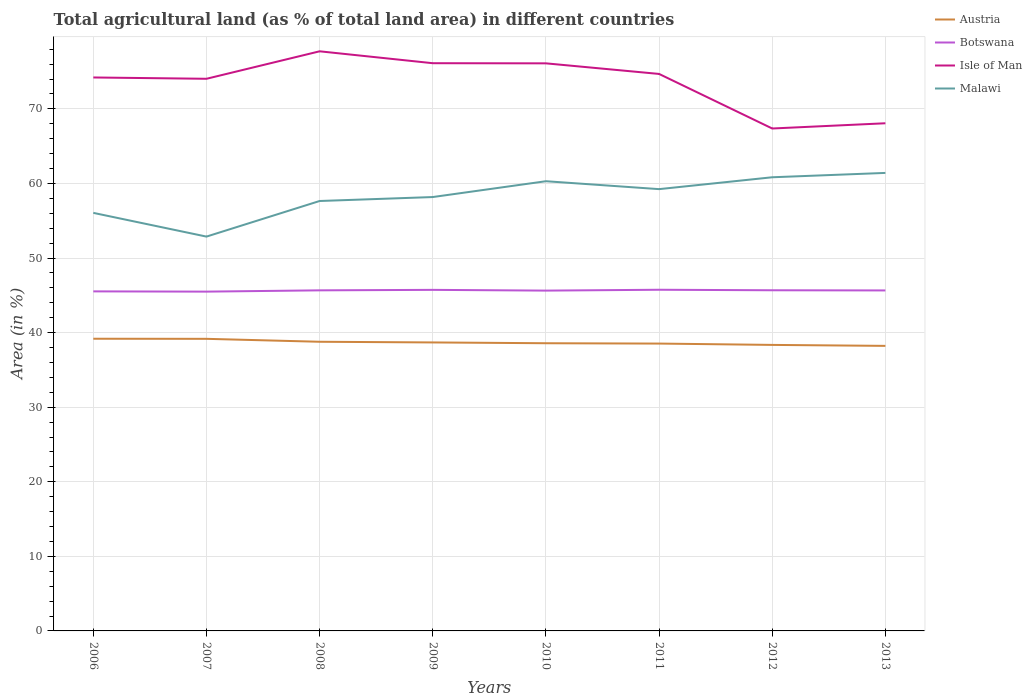Does the line corresponding to Botswana intersect with the line corresponding to Malawi?
Ensure brevity in your answer.  No. Across all years, what is the maximum percentage of agricultural land in Isle of Man?
Keep it short and to the point. 67.37. In which year was the percentage of agricultural land in Austria maximum?
Make the answer very short. 2013. What is the total percentage of agricultural land in Malawi in the graph?
Your answer should be compact. 3.18. What is the difference between the highest and the second highest percentage of agricultural land in Isle of Man?
Make the answer very short. 10.35. Is the percentage of agricultural land in Malawi strictly greater than the percentage of agricultural land in Isle of Man over the years?
Provide a succinct answer. Yes. How many lines are there?
Your answer should be very brief. 4. Are the values on the major ticks of Y-axis written in scientific E-notation?
Keep it short and to the point. No. Where does the legend appear in the graph?
Give a very brief answer. Top right. How many legend labels are there?
Your answer should be very brief. 4. What is the title of the graph?
Offer a very short reply. Total agricultural land (as % of total land area) in different countries. What is the label or title of the X-axis?
Provide a short and direct response. Years. What is the label or title of the Y-axis?
Your answer should be compact. Area (in %). What is the Area (in %) of Austria in 2006?
Ensure brevity in your answer.  39.18. What is the Area (in %) in Botswana in 2006?
Your answer should be compact. 45.53. What is the Area (in %) in Isle of Man in 2006?
Offer a very short reply. 74.21. What is the Area (in %) of Malawi in 2006?
Your response must be concise. 56.06. What is the Area (in %) of Austria in 2007?
Your answer should be compact. 39.17. What is the Area (in %) of Botswana in 2007?
Ensure brevity in your answer.  45.5. What is the Area (in %) in Isle of Man in 2007?
Offer a terse response. 74.04. What is the Area (in %) in Malawi in 2007?
Provide a succinct answer. 52.87. What is the Area (in %) in Austria in 2008?
Provide a short and direct response. 38.77. What is the Area (in %) in Botswana in 2008?
Provide a short and direct response. 45.67. What is the Area (in %) of Isle of Man in 2008?
Give a very brief answer. 77.72. What is the Area (in %) in Malawi in 2008?
Your response must be concise. 57.65. What is the Area (in %) of Austria in 2009?
Keep it short and to the point. 38.68. What is the Area (in %) in Botswana in 2009?
Provide a short and direct response. 45.73. What is the Area (in %) in Isle of Man in 2009?
Ensure brevity in your answer.  76.12. What is the Area (in %) of Malawi in 2009?
Your answer should be very brief. 58.18. What is the Area (in %) of Austria in 2010?
Your response must be concise. 38.58. What is the Area (in %) of Botswana in 2010?
Offer a very short reply. 45.63. What is the Area (in %) in Isle of Man in 2010?
Make the answer very short. 76.11. What is the Area (in %) in Malawi in 2010?
Give a very brief answer. 60.3. What is the Area (in %) of Austria in 2011?
Offer a terse response. 38.53. What is the Area (in %) of Botswana in 2011?
Your response must be concise. 45.75. What is the Area (in %) in Isle of Man in 2011?
Your response must be concise. 74.68. What is the Area (in %) in Malawi in 2011?
Give a very brief answer. 59.24. What is the Area (in %) in Austria in 2012?
Your answer should be compact. 38.35. What is the Area (in %) of Botswana in 2012?
Keep it short and to the point. 45.68. What is the Area (in %) in Isle of Man in 2012?
Provide a succinct answer. 67.37. What is the Area (in %) of Malawi in 2012?
Offer a very short reply. 60.83. What is the Area (in %) of Austria in 2013?
Ensure brevity in your answer.  38.22. What is the Area (in %) in Botswana in 2013?
Give a very brief answer. 45.65. What is the Area (in %) of Isle of Man in 2013?
Make the answer very short. 68.07. What is the Area (in %) in Malawi in 2013?
Provide a short and direct response. 61.41. Across all years, what is the maximum Area (in %) in Austria?
Give a very brief answer. 39.18. Across all years, what is the maximum Area (in %) of Botswana?
Offer a very short reply. 45.75. Across all years, what is the maximum Area (in %) in Isle of Man?
Make the answer very short. 77.72. Across all years, what is the maximum Area (in %) of Malawi?
Your answer should be very brief. 61.41. Across all years, what is the minimum Area (in %) of Austria?
Provide a short and direct response. 38.22. Across all years, what is the minimum Area (in %) in Botswana?
Offer a terse response. 45.5. Across all years, what is the minimum Area (in %) of Isle of Man?
Your answer should be very brief. 67.37. Across all years, what is the minimum Area (in %) of Malawi?
Ensure brevity in your answer.  52.87. What is the total Area (in %) of Austria in the graph?
Your response must be concise. 309.48. What is the total Area (in %) in Botswana in the graph?
Your answer should be compact. 365.14. What is the total Area (in %) in Isle of Man in the graph?
Ensure brevity in your answer.  588.32. What is the total Area (in %) in Malawi in the graph?
Provide a succinct answer. 466.54. What is the difference between the Area (in %) of Austria in 2006 and that in 2007?
Your response must be concise. 0.01. What is the difference between the Area (in %) in Botswana in 2006 and that in 2007?
Your answer should be very brief. 0.03. What is the difference between the Area (in %) of Isle of Man in 2006 and that in 2007?
Ensure brevity in your answer.  0.18. What is the difference between the Area (in %) of Malawi in 2006 and that in 2007?
Offer a terse response. 3.18. What is the difference between the Area (in %) in Austria in 2006 and that in 2008?
Make the answer very short. 0.41. What is the difference between the Area (in %) in Botswana in 2006 and that in 2008?
Your answer should be compact. -0.14. What is the difference between the Area (in %) of Isle of Man in 2006 and that in 2008?
Keep it short and to the point. -3.51. What is the difference between the Area (in %) of Malawi in 2006 and that in 2008?
Your answer should be compact. -1.59. What is the difference between the Area (in %) of Austria in 2006 and that in 2009?
Provide a succinct answer. 0.5. What is the difference between the Area (in %) in Botswana in 2006 and that in 2009?
Provide a short and direct response. -0.2. What is the difference between the Area (in %) in Isle of Man in 2006 and that in 2009?
Provide a short and direct response. -1.91. What is the difference between the Area (in %) in Malawi in 2006 and that in 2009?
Offer a terse response. -2.12. What is the difference between the Area (in %) in Austria in 2006 and that in 2010?
Your response must be concise. 0.6. What is the difference between the Area (in %) in Botswana in 2006 and that in 2010?
Ensure brevity in your answer.  -0.1. What is the difference between the Area (in %) in Isle of Man in 2006 and that in 2010?
Provide a succinct answer. -1.89. What is the difference between the Area (in %) in Malawi in 2006 and that in 2010?
Give a very brief answer. -4.24. What is the difference between the Area (in %) of Austria in 2006 and that in 2011?
Provide a short and direct response. 0.65. What is the difference between the Area (in %) in Botswana in 2006 and that in 2011?
Keep it short and to the point. -0.22. What is the difference between the Area (in %) in Isle of Man in 2006 and that in 2011?
Ensure brevity in your answer.  -0.47. What is the difference between the Area (in %) of Malawi in 2006 and that in 2011?
Offer a very short reply. -3.18. What is the difference between the Area (in %) of Austria in 2006 and that in 2012?
Keep it short and to the point. 0.83. What is the difference between the Area (in %) of Botswana in 2006 and that in 2012?
Offer a terse response. -0.15. What is the difference between the Area (in %) in Isle of Man in 2006 and that in 2012?
Provide a short and direct response. 6.84. What is the difference between the Area (in %) in Malawi in 2006 and that in 2012?
Your response must be concise. -4.77. What is the difference between the Area (in %) in Austria in 2006 and that in 2013?
Offer a terse response. 0.96. What is the difference between the Area (in %) of Botswana in 2006 and that in 2013?
Keep it short and to the point. -0.13. What is the difference between the Area (in %) of Isle of Man in 2006 and that in 2013?
Provide a short and direct response. 6.14. What is the difference between the Area (in %) of Malawi in 2006 and that in 2013?
Make the answer very short. -5.36. What is the difference between the Area (in %) of Austria in 2007 and that in 2008?
Provide a succinct answer. 0.39. What is the difference between the Area (in %) of Botswana in 2007 and that in 2008?
Provide a short and direct response. -0.17. What is the difference between the Area (in %) of Isle of Man in 2007 and that in 2008?
Your answer should be compact. -3.68. What is the difference between the Area (in %) of Malawi in 2007 and that in 2008?
Make the answer very short. -4.77. What is the difference between the Area (in %) of Austria in 2007 and that in 2009?
Make the answer very short. 0.48. What is the difference between the Area (in %) of Botswana in 2007 and that in 2009?
Your response must be concise. -0.24. What is the difference between the Area (in %) of Isle of Man in 2007 and that in 2009?
Offer a very short reply. -2.09. What is the difference between the Area (in %) of Malawi in 2007 and that in 2009?
Offer a very short reply. -5.3. What is the difference between the Area (in %) in Austria in 2007 and that in 2010?
Your answer should be compact. 0.59. What is the difference between the Area (in %) of Botswana in 2007 and that in 2010?
Provide a short and direct response. -0.14. What is the difference between the Area (in %) in Isle of Man in 2007 and that in 2010?
Your answer should be compact. -2.07. What is the difference between the Area (in %) of Malawi in 2007 and that in 2010?
Give a very brief answer. -7.42. What is the difference between the Area (in %) of Austria in 2007 and that in 2011?
Make the answer very short. 0.64. What is the difference between the Area (in %) of Botswana in 2007 and that in 2011?
Keep it short and to the point. -0.25. What is the difference between the Area (in %) in Isle of Man in 2007 and that in 2011?
Offer a terse response. -0.65. What is the difference between the Area (in %) of Malawi in 2007 and that in 2011?
Make the answer very short. -6.36. What is the difference between the Area (in %) in Austria in 2007 and that in 2012?
Offer a terse response. 0.82. What is the difference between the Area (in %) of Botswana in 2007 and that in 2012?
Offer a very short reply. -0.18. What is the difference between the Area (in %) in Malawi in 2007 and that in 2012?
Provide a succinct answer. -7.96. What is the difference between the Area (in %) of Austria in 2007 and that in 2013?
Your answer should be compact. 0.94. What is the difference between the Area (in %) in Botswana in 2007 and that in 2013?
Your response must be concise. -0.16. What is the difference between the Area (in %) in Isle of Man in 2007 and that in 2013?
Provide a succinct answer. 5.96. What is the difference between the Area (in %) in Malawi in 2007 and that in 2013?
Ensure brevity in your answer.  -8.54. What is the difference between the Area (in %) in Austria in 2008 and that in 2009?
Offer a terse response. 0.09. What is the difference between the Area (in %) of Botswana in 2008 and that in 2009?
Your answer should be very brief. -0.07. What is the difference between the Area (in %) of Isle of Man in 2008 and that in 2009?
Your response must be concise. 1.6. What is the difference between the Area (in %) of Malawi in 2008 and that in 2009?
Offer a terse response. -0.53. What is the difference between the Area (in %) of Austria in 2008 and that in 2010?
Your answer should be very brief. 0.2. What is the difference between the Area (in %) in Botswana in 2008 and that in 2010?
Your answer should be very brief. 0.04. What is the difference between the Area (in %) of Isle of Man in 2008 and that in 2010?
Provide a short and direct response. 1.61. What is the difference between the Area (in %) of Malawi in 2008 and that in 2010?
Offer a very short reply. -2.65. What is the difference between the Area (in %) of Austria in 2008 and that in 2011?
Make the answer very short. 0.24. What is the difference between the Area (in %) of Botswana in 2008 and that in 2011?
Make the answer very short. -0.08. What is the difference between the Area (in %) of Isle of Man in 2008 and that in 2011?
Offer a very short reply. 3.04. What is the difference between the Area (in %) in Malawi in 2008 and that in 2011?
Your response must be concise. -1.59. What is the difference between the Area (in %) in Austria in 2008 and that in 2012?
Keep it short and to the point. 0.42. What is the difference between the Area (in %) of Botswana in 2008 and that in 2012?
Give a very brief answer. -0.01. What is the difference between the Area (in %) of Isle of Man in 2008 and that in 2012?
Your answer should be very brief. 10.35. What is the difference between the Area (in %) of Malawi in 2008 and that in 2012?
Ensure brevity in your answer.  -3.18. What is the difference between the Area (in %) in Austria in 2008 and that in 2013?
Give a very brief answer. 0.55. What is the difference between the Area (in %) of Botswana in 2008 and that in 2013?
Provide a succinct answer. 0.01. What is the difference between the Area (in %) in Isle of Man in 2008 and that in 2013?
Your response must be concise. 9.65. What is the difference between the Area (in %) of Malawi in 2008 and that in 2013?
Your response must be concise. -3.77. What is the difference between the Area (in %) in Austria in 2009 and that in 2010?
Keep it short and to the point. 0.11. What is the difference between the Area (in %) in Botswana in 2009 and that in 2010?
Ensure brevity in your answer.  0.1. What is the difference between the Area (in %) in Isle of Man in 2009 and that in 2010?
Your answer should be very brief. 0.02. What is the difference between the Area (in %) in Malawi in 2009 and that in 2010?
Your response must be concise. -2.12. What is the difference between the Area (in %) of Austria in 2009 and that in 2011?
Ensure brevity in your answer.  0.15. What is the difference between the Area (in %) in Botswana in 2009 and that in 2011?
Keep it short and to the point. -0.01. What is the difference between the Area (in %) in Isle of Man in 2009 and that in 2011?
Your answer should be very brief. 1.44. What is the difference between the Area (in %) of Malawi in 2009 and that in 2011?
Your response must be concise. -1.06. What is the difference between the Area (in %) of Austria in 2009 and that in 2012?
Make the answer very short. 0.33. What is the difference between the Area (in %) in Botswana in 2009 and that in 2012?
Provide a short and direct response. 0.05. What is the difference between the Area (in %) in Isle of Man in 2009 and that in 2012?
Give a very brief answer. 8.75. What is the difference between the Area (in %) in Malawi in 2009 and that in 2012?
Ensure brevity in your answer.  -2.65. What is the difference between the Area (in %) of Austria in 2009 and that in 2013?
Give a very brief answer. 0.46. What is the difference between the Area (in %) in Botswana in 2009 and that in 2013?
Your answer should be very brief. 0.08. What is the difference between the Area (in %) in Isle of Man in 2009 and that in 2013?
Give a very brief answer. 8.05. What is the difference between the Area (in %) in Malawi in 2009 and that in 2013?
Offer a terse response. -3.23. What is the difference between the Area (in %) in Austria in 2010 and that in 2011?
Your response must be concise. 0.05. What is the difference between the Area (in %) in Botswana in 2010 and that in 2011?
Your response must be concise. -0.11. What is the difference between the Area (in %) in Isle of Man in 2010 and that in 2011?
Make the answer very short. 1.42. What is the difference between the Area (in %) in Malawi in 2010 and that in 2011?
Provide a succinct answer. 1.06. What is the difference between the Area (in %) of Austria in 2010 and that in 2012?
Ensure brevity in your answer.  0.23. What is the difference between the Area (in %) in Botswana in 2010 and that in 2012?
Provide a short and direct response. -0.05. What is the difference between the Area (in %) in Isle of Man in 2010 and that in 2012?
Make the answer very short. 8.74. What is the difference between the Area (in %) in Malawi in 2010 and that in 2012?
Give a very brief answer. -0.53. What is the difference between the Area (in %) of Austria in 2010 and that in 2013?
Provide a succinct answer. 0.35. What is the difference between the Area (in %) of Botswana in 2010 and that in 2013?
Offer a very short reply. -0.02. What is the difference between the Area (in %) of Isle of Man in 2010 and that in 2013?
Keep it short and to the point. 8.04. What is the difference between the Area (in %) in Malawi in 2010 and that in 2013?
Your answer should be very brief. -1.11. What is the difference between the Area (in %) of Austria in 2011 and that in 2012?
Ensure brevity in your answer.  0.18. What is the difference between the Area (in %) in Botswana in 2011 and that in 2012?
Offer a terse response. 0.07. What is the difference between the Area (in %) in Isle of Man in 2011 and that in 2012?
Offer a terse response. 7.32. What is the difference between the Area (in %) of Malawi in 2011 and that in 2012?
Provide a short and direct response. -1.59. What is the difference between the Area (in %) of Austria in 2011 and that in 2013?
Your response must be concise. 0.31. What is the difference between the Area (in %) of Botswana in 2011 and that in 2013?
Offer a very short reply. 0.09. What is the difference between the Area (in %) in Isle of Man in 2011 and that in 2013?
Provide a succinct answer. 6.61. What is the difference between the Area (in %) in Malawi in 2011 and that in 2013?
Keep it short and to the point. -2.17. What is the difference between the Area (in %) of Austria in 2012 and that in 2013?
Ensure brevity in your answer.  0.13. What is the difference between the Area (in %) of Botswana in 2012 and that in 2013?
Give a very brief answer. 0.02. What is the difference between the Area (in %) in Isle of Man in 2012 and that in 2013?
Your answer should be compact. -0.7. What is the difference between the Area (in %) of Malawi in 2012 and that in 2013?
Ensure brevity in your answer.  -0.58. What is the difference between the Area (in %) of Austria in 2006 and the Area (in %) of Botswana in 2007?
Keep it short and to the point. -6.32. What is the difference between the Area (in %) of Austria in 2006 and the Area (in %) of Isle of Man in 2007?
Ensure brevity in your answer.  -34.86. What is the difference between the Area (in %) in Austria in 2006 and the Area (in %) in Malawi in 2007?
Provide a short and direct response. -13.7. What is the difference between the Area (in %) in Botswana in 2006 and the Area (in %) in Isle of Man in 2007?
Give a very brief answer. -28.51. What is the difference between the Area (in %) of Botswana in 2006 and the Area (in %) of Malawi in 2007?
Your answer should be very brief. -7.34. What is the difference between the Area (in %) of Isle of Man in 2006 and the Area (in %) of Malawi in 2007?
Keep it short and to the point. 21.34. What is the difference between the Area (in %) of Austria in 2006 and the Area (in %) of Botswana in 2008?
Keep it short and to the point. -6.49. What is the difference between the Area (in %) of Austria in 2006 and the Area (in %) of Isle of Man in 2008?
Offer a terse response. -38.54. What is the difference between the Area (in %) in Austria in 2006 and the Area (in %) in Malawi in 2008?
Offer a very short reply. -18.47. What is the difference between the Area (in %) in Botswana in 2006 and the Area (in %) in Isle of Man in 2008?
Offer a very short reply. -32.19. What is the difference between the Area (in %) in Botswana in 2006 and the Area (in %) in Malawi in 2008?
Offer a terse response. -12.12. What is the difference between the Area (in %) of Isle of Man in 2006 and the Area (in %) of Malawi in 2008?
Make the answer very short. 16.56. What is the difference between the Area (in %) of Austria in 2006 and the Area (in %) of Botswana in 2009?
Provide a succinct answer. -6.55. What is the difference between the Area (in %) of Austria in 2006 and the Area (in %) of Isle of Man in 2009?
Make the answer very short. -36.94. What is the difference between the Area (in %) of Austria in 2006 and the Area (in %) of Malawi in 2009?
Your answer should be very brief. -19. What is the difference between the Area (in %) in Botswana in 2006 and the Area (in %) in Isle of Man in 2009?
Offer a very short reply. -30.59. What is the difference between the Area (in %) of Botswana in 2006 and the Area (in %) of Malawi in 2009?
Make the answer very short. -12.65. What is the difference between the Area (in %) in Isle of Man in 2006 and the Area (in %) in Malawi in 2009?
Give a very brief answer. 16.03. What is the difference between the Area (in %) in Austria in 2006 and the Area (in %) in Botswana in 2010?
Offer a very short reply. -6.45. What is the difference between the Area (in %) in Austria in 2006 and the Area (in %) in Isle of Man in 2010?
Offer a terse response. -36.93. What is the difference between the Area (in %) of Austria in 2006 and the Area (in %) of Malawi in 2010?
Your answer should be compact. -21.12. What is the difference between the Area (in %) in Botswana in 2006 and the Area (in %) in Isle of Man in 2010?
Provide a succinct answer. -30.58. What is the difference between the Area (in %) of Botswana in 2006 and the Area (in %) of Malawi in 2010?
Provide a succinct answer. -14.77. What is the difference between the Area (in %) of Isle of Man in 2006 and the Area (in %) of Malawi in 2010?
Your response must be concise. 13.91. What is the difference between the Area (in %) in Austria in 2006 and the Area (in %) in Botswana in 2011?
Your answer should be compact. -6.57. What is the difference between the Area (in %) in Austria in 2006 and the Area (in %) in Isle of Man in 2011?
Provide a succinct answer. -35.51. What is the difference between the Area (in %) in Austria in 2006 and the Area (in %) in Malawi in 2011?
Provide a short and direct response. -20.06. What is the difference between the Area (in %) of Botswana in 2006 and the Area (in %) of Isle of Man in 2011?
Offer a terse response. -29.15. What is the difference between the Area (in %) in Botswana in 2006 and the Area (in %) in Malawi in 2011?
Offer a very short reply. -13.71. What is the difference between the Area (in %) of Isle of Man in 2006 and the Area (in %) of Malawi in 2011?
Your answer should be compact. 14.97. What is the difference between the Area (in %) in Austria in 2006 and the Area (in %) in Botswana in 2012?
Your response must be concise. -6.5. What is the difference between the Area (in %) in Austria in 2006 and the Area (in %) in Isle of Man in 2012?
Keep it short and to the point. -28.19. What is the difference between the Area (in %) of Austria in 2006 and the Area (in %) of Malawi in 2012?
Your response must be concise. -21.65. What is the difference between the Area (in %) of Botswana in 2006 and the Area (in %) of Isle of Man in 2012?
Your answer should be very brief. -21.84. What is the difference between the Area (in %) of Botswana in 2006 and the Area (in %) of Malawi in 2012?
Make the answer very short. -15.3. What is the difference between the Area (in %) in Isle of Man in 2006 and the Area (in %) in Malawi in 2012?
Provide a short and direct response. 13.38. What is the difference between the Area (in %) of Austria in 2006 and the Area (in %) of Botswana in 2013?
Make the answer very short. -6.48. What is the difference between the Area (in %) in Austria in 2006 and the Area (in %) in Isle of Man in 2013?
Make the answer very short. -28.89. What is the difference between the Area (in %) in Austria in 2006 and the Area (in %) in Malawi in 2013?
Offer a terse response. -22.23. What is the difference between the Area (in %) of Botswana in 2006 and the Area (in %) of Isle of Man in 2013?
Your answer should be compact. -22.54. What is the difference between the Area (in %) of Botswana in 2006 and the Area (in %) of Malawi in 2013?
Give a very brief answer. -15.88. What is the difference between the Area (in %) of Isle of Man in 2006 and the Area (in %) of Malawi in 2013?
Provide a succinct answer. 12.8. What is the difference between the Area (in %) of Austria in 2007 and the Area (in %) of Botswana in 2008?
Keep it short and to the point. -6.5. What is the difference between the Area (in %) in Austria in 2007 and the Area (in %) in Isle of Man in 2008?
Ensure brevity in your answer.  -38.55. What is the difference between the Area (in %) in Austria in 2007 and the Area (in %) in Malawi in 2008?
Offer a terse response. -18.48. What is the difference between the Area (in %) in Botswana in 2007 and the Area (in %) in Isle of Man in 2008?
Your answer should be compact. -32.22. What is the difference between the Area (in %) in Botswana in 2007 and the Area (in %) in Malawi in 2008?
Offer a terse response. -12.15. What is the difference between the Area (in %) of Isle of Man in 2007 and the Area (in %) of Malawi in 2008?
Give a very brief answer. 16.39. What is the difference between the Area (in %) in Austria in 2007 and the Area (in %) in Botswana in 2009?
Keep it short and to the point. -6.57. What is the difference between the Area (in %) in Austria in 2007 and the Area (in %) in Isle of Man in 2009?
Ensure brevity in your answer.  -36.96. What is the difference between the Area (in %) in Austria in 2007 and the Area (in %) in Malawi in 2009?
Provide a succinct answer. -19.01. What is the difference between the Area (in %) of Botswana in 2007 and the Area (in %) of Isle of Man in 2009?
Your answer should be very brief. -30.63. What is the difference between the Area (in %) of Botswana in 2007 and the Area (in %) of Malawi in 2009?
Make the answer very short. -12.68. What is the difference between the Area (in %) in Isle of Man in 2007 and the Area (in %) in Malawi in 2009?
Make the answer very short. 15.86. What is the difference between the Area (in %) in Austria in 2007 and the Area (in %) in Botswana in 2010?
Ensure brevity in your answer.  -6.47. What is the difference between the Area (in %) in Austria in 2007 and the Area (in %) in Isle of Man in 2010?
Your response must be concise. -36.94. What is the difference between the Area (in %) of Austria in 2007 and the Area (in %) of Malawi in 2010?
Make the answer very short. -21.13. What is the difference between the Area (in %) of Botswana in 2007 and the Area (in %) of Isle of Man in 2010?
Offer a very short reply. -30.61. What is the difference between the Area (in %) in Botswana in 2007 and the Area (in %) in Malawi in 2010?
Offer a terse response. -14.8. What is the difference between the Area (in %) in Isle of Man in 2007 and the Area (in %) in Malawi in 2010?
Offer a terse response. 13.74. What is the difference between the Area (in %) in Austria in 2007 and the Area (in %) in Botswana in 2011?
Keep it short and to the point. -6.58. What is the difference between the Area (in %) in Austria in 2007 and the Area (in %) in Isle of Man in 2011?
Make the answer very short. -35.52. What is the difference between the Area (in %) in Austria in 2007 and the Area (in %) in Malawi in 2011?
Provide a succinct answer. -20.07. What is the difference between the Area (in %) in Botswana in 2007 and the Area (in %) in Isle of Man in 2011?
Give a very brief answer. -29.19. What is the difference between the Area (in %) of Botswana in 2007 and the Area (in %) of Malawi in 2011?
Offer a terse response. -13.74. What is the difference between the Area (in %) in Isle of Man in 2007 and the Area (in %) in Malawi in 2011?
Offer a terse response. 14.8. What is the difference between the Area (in %) of Austria in 2007 and the Area (in %) of Botswana in 2012?
Offer a very short reply. -6.51. What is the difference between the Area (in %) in Austria in 2007 and the Area (in %) in Isle of Man in 2012?
Provide a succinct answer. -28.2. What is the difference between the Area (in %) of Austria in 2007 and the Area (in %) of Malawi in 2012?
Provide a succinct answer. -21.66. What is the difference between the Area (in %) in Botswana in 2007 and the Area (in %) in Isle of Man in 2012?
Offer a very short reply. -21.87. What is the difference between the Area (in %) of Botswana in 2007 and the Area (in %) of Malawi in 2012?
Provide a succinct answer. -15.33. What is the difference between the Area (in %) in Isle of Man in 2007 and the Area (in %) in Malawi in 2012?
Give a very brief answer. 13.21. What is the difference between the Area (in %) in Austria in 2007 and the Area (in %) in Botswana in 2013?
Ensure brevity in your answer.  -6.49. What is the difference between the Area (in %) in Austria in 2007 and the Area (in %) in Isle of Man in 2013?
Provide a short and direct response. -28.9. What is the difference between the Area (in %) in Austria in 2007 and the Area (in %) in Malawi in 2013?
Provide a succinct answer. -22.25. What is the difference between the Area (in %) of Botswana in 2007 and the Area (in %) of Isle of Man in 2013?
Keep it short and to the point. -22.57. What is the difference between the Area (in %) in Botswana in 2007 and the Area (in %) in Malawi in 2013?
Keep it short and to the point. -15.92. What is the difference between the Area (in %) of Isle of Man in 2007 and the Area (in %) of Malawi in 2013?
Make the answer very short. 12.62. What is the difference between the Area (in %) of Austria in 2008 and the Area (in %) of Botswana in 2009?
Offer a terse response. -6.96. What is the difference between the Area (in %) in Austria in 2008 and the Area (in %) in Isle of Man in 2009?
Offer a terse response. -37.35. What is the difference between the Area (in %) in Austria in 2008 and the Area (in %) in Malawi in 2009?
Provide a succinct answer. -19.4. What is the difference between the Area (in %) in Botswana in 2008 and the Area (in %) in Isle of Man in 2009?
Provide a short and direct response. -30.46. What is the difference between the Area (in %) of Botswana in 2008 and the Area (in %) of Malawi in 2009?
Keep it short and to the point. -12.51. What is the difference between the Area (in %) in Isle of Man in 2008 and the Area (in %) in Malawi in 2009?
Provide a succinct answer. 19.54. What is the difference between the Area (in %) in Austria in 2008 and the Area (in %) in Botswana in 2010?
Your answer should be compact. -6.86. What is the difference between the Area (in %) in Austria in 2008 and the Area (in %) in Isle of Man in 2010?
Your answer should be compact. -37.33. What is the difference between the Area (in %) of Austria in 2008 and the Area (in %) of Malawi in 2010?
Give a very brief answer. -21.53. What is the difference between the Area (in %) in Botswana in 2008 and the Area (in %) in Isle of Man in 2010?
Keep it short and to the point. -30.44. What is the difference between the Area (in %) in Botswana in 2008 and the Area (in %) in Malawi in 2010?
Provide a short and direct response. -14.63. What is the difference between the Area (in %) in Isle of Man in 2008 and the Area (in %) in Malawi in 2010?
Make the answer very short. 17.42. What is the difference between the Area (in %) in Austria in 2008 and the Area (in %) in Botswana in 2011?
Provide a succinct answer. -6.97. What is the difference between the Area (in %) in Austria in 2008 and the Area (in %) in Isle of Man in 2011?
Provide a short and direct response. -35.91. What is the difference between the Area (in %) in Austria in 2008 and the Area (in %) in Malawi in 2011?
Your response must be concise. -20.47. What is the difference between the Area (in %) of Botswana in 2008 and the Area (in %) of Isle of Man in 2011?
Provide a succinct answer. -29.02. What is the difference between the Area (in %) in Botswana in 2008 and the Area (in %) in Malawi in 2011?
Offer a terse response. -13.57. What is the difference between the Area (in %) of Isle of Man in 2008 and the Area (in %) of Malawi in 2011?
Offer a terse response. 18.48. What is the difference between the Area (in %) in Austria in 2008 and the Area (in %) in Botswana in 2012?
Ensure brevity in your answer.  -6.9. What is the difference between the Area (in %) in Austria in 2008 and the Area (in %) in Isle of Man in 2012?
Keep it short and to the point. -28.6. What is the difference between the Area (in %) in Austria in 2008 and the Area (in %) in Malawi in 2012?
Give a very brief answer. -22.06. What is the difference between the Area (in %) in Botswana in 2008 and the Area (in %) in Isle of Man in 2012?
Offer a terse response. -21.7. What is the difference between the Area (in %) of Botswana in 2008 and the Area (in %) of Malawi in 2012?
Give a very brief answer. -15.16. What is the difference between the Area (in %) of Isle of Man in 2008 and the Area (in %) of Malawi in 2012?
Offer a very short reply. 16.89. What is the difference between the Area (in %) of Austria in 2008 and the Area (in %) of Botswana in 2013?
Provide a short and direct response. -6.88. What is the difference between the Area (in %) in Austria in 2008 and the Area (in %) in Isle of Man in 2013?
Provide a short and direct response. -29.3. What is the difference between the Area (in %) in Austria in 2008 and the Area (in %) in Malawi in 2013?
Give a very brief answer. -22.64. What is the difference between the Area (in %) in Botswana in 2008 and the Area (in %) in Isle of Man in 2013?
Your answer should be compact. -22.4. What is the difference between the Area (in %) in Botswana in 2008 and the Area (in %) in Malawi in 2013?
Offer a very short reply. -15.75. What is the difference between the Area (in %) of Isle of Man in 2008 and the Area (in %) of Malawi in 2013?
Offer a very short reply. 16.31. What is the difference between the Area (in %) in Austria in 2009 and the Area (in %) in Botswana in 2010?
Give a very brief answer. -6.95. What is the difference between the Area (in %) of Austria in 2009 and the Area (in %) of Isle of Man in 2010?
Your response must be concise. -37.42. What is the difference between the Area (in %) in Austria in 2009 and the Area (in %) in Malawi in 2010?
Provide a short and direct response. -21.62. What is the difference between the Area (in %) in Botswana in 2009 and the Area (in %) in Isle of Man in 2010?
Make the answer very short. -30.37. What is the difference between the Area (in %) of Botswana in 2009 and the Area (in %) of Malawi in 2010?
Provide a short and direct response. -14.57. What is the difference between the Area (in %) of Isle of Man in 2009 and the Area (in %) of Malawi in 2010?
Your answer should be compact. 15.82. What is the difference between the Area (in %) in Austria in 2009 and the Area (in %) in Botswana in 2011?
Provide a succinct answer. -7.06. What is the difference between the Area (in %) in Austria in 2009 and the Area (in %) in Isle of Man in 2011?
Your answer should be very brief. -36. What is the difference between the Area (in %) in Austria in 2009 and the Area (in %) in Malawi in 2011?
Your answer should be compact. -20.56. What is the difference between the Area (in %) in Botswana in 2009 and the Area (in %) in Isle of Man in 2011?
Ensure brevity in your answer.  -28.95. What is the difference between the Area (in %) in Botswana in 2009 and the Area (in %) in Malawi in 2011?
Your answer should be very brief. -13.51. What is the difference between the Area (in %) in Isle of Man in 2009 and the Area (in %) in Malawi in 2011?
Your answer should be compact. 16.88. What is the difference between the Area (in %) of Austria in 2009 and the Area (in %) of Botswana in 2012?
Offer a terse response. -7. What is the difference between the Area (in %) of Austria in 2009 and the Area (in %) of Isle of Man in 2012?
Make the answer very short. -28.69. What is the difference between the Area (in %) in Austria in 2009 and the Area (in %) in Malawi in 2012?
Your response must be concise. -22.15. What is the difference between the Area (in %) in Botswana in 2009 and the Area (in %) in Isle of Man in 2012?
Provide a succinct answer. -21.64. What is the difference between the Area (in %) of Botswana in 2009 and the Area (in %) of Malawi in 2012?
Your answer should be compact. -15.1. What is the difference between the Area (in %) in Isle of Man in 2009 and the Area (in %) in Malawi in 2012?
Your answer should be compact. 15.29. What is the difference between the Area (in %) in Austria in 2009 and the Area (in %) in Botswana in 2013?
Your response must be concise. -6.97. What is the difference between the Area (in %) in Austria in 2009 and the Area (in %) in Isle of Man in 2013?
Your answer should be very brief. -29.39. What is the difference between the Area (in %) of Austria in 2009 and the Area (in %) of Malawi in 2013?
Your answer should be very brief. -22.73. What is the difference between the Area (in %) in Botswana in 2009 and the Area (in %) in Isle of Man in 2013?
Your answer should be very brief. -22.34. What is the difference between the Area (in %) in Botswana in 2009 and the Area (in %) in Malawi in 2013?
Provide a succinct answer. -15.68. What is the difference between the Area (in %) in Isle of Man in 2009 and the Area (in %) in Malawi in 2013?
Your response must be concise. 14.71. What is the difference between the Area (in %) in Austria in 2010 and the Area (in %) in Botswana in 2011?
Keep it short and to the point. -7.17. What is the difference between the Area (in %) of Austria in 2010 and the Area (in %) of Isle of Man in 2011?
Make the answer very short. -36.11. What is the difference between the Area (in %) of Austria in 2010 and the Area (in %) of Malawi in 2011?
Make the answer very short. -20.66. What is the difference between the Area (in %) in Botswana in 2010 and the Area (in %) in Isle of Man in 2011?
Offer a terse response. -29.05. What is the difference between the Area (in %) of Botswana in 2010 and the Area (in %) of Malawi in 2011?
Your answer should be very brief. -13.61. What is the difference between the Area (in %) in Isle of Man in 2010 and the Area (in %) in Malawi in 2011?
Provide a short and direct response. 16.87. What is the difference between the Area (in %) in Austria in 2010 and the Area (in %) in Botswana in 2012?
Provide a succinct answer. -7.1. What is the difference between the Area (in %) of Austria in 2010 and the Area (in %) of Isle of Man in 2012?
Offer a very short reply. -28.79. What is the difference between the Area (in %) of Austria in 2010 and the Area (in %) of Malawi in 2012?
Ensure brevity in your answer.  -22.25. What is the difference between the Area (in %) of Botswana in 2010 and the Area (in %) of Isle of Man in 2012?
Offer a terse response. -21.74. What is the difference between the Area (in %) of Botswana in 2010 and the Area (in %) of Malawi in 2012?
Keep it short and to the point. -15.2. What is the difference between the Area (in %) of Isle of Man in 2010 and the Area (in %) of Malawi in 2012?
Provide a succinct answer. 15.28. What is the difference between the Area (in %) of Austria in 2010 and the Area (in %) of Botswana in 2013?
Your answer should be very brief. -7.08. What is the difference between the Area (in %) in Austria in 2010 and the Area (in %) in Isle of Man in 2013?
Provide a short and direct response. -29.49. What is the difference between the Area (in %) of Austria in 2010 and the Area (in %) of Malawi in 2013?
Offer a terse response. -22.84. What is the difference between the Area (in %) in Botswana in 2010 and the Area (in %) in Isle of Man in 2013?
Provide a short and direct response. -22.44. What is the difference between the Area (in %) of Botswana in 2010 and the Area (in %) of Malawi in 2013?
Offer a terse response. -15.78. What is the difference between the Area (in %) of Isle of Man in 2010 and the Area (in %) of Malawi in 2013?
Your answer should be very brief. 14.69. What is the difference between the Area (in %) in Austria in 2011 and the Area (in %) in Botswana in 2012?
Provide a short and direct response. -7.15. What is the difference between the Area (in %) in Austria in 2011 and the Area (in %) in Isle of Man in 2012?
Provide a short and direct response. -28.84. What is the difference between the Area (in %) of Austria in 2011 and the Area (in %) of Malawi in 2012?
Your response must be concise. -22.3. What is the difference between the Area (in %) in Botswana in 2011 and the Area (in %) in Isle of Man in 2012?
Ensure brevity in your answer.  -21.62. What is the difference between the Area (in %) in Botswana in 2011 and the Area (in %) in Malawi in 2012?
Give a very brief answer. -15.08. What is the difference between the Area (in %) of Isle of Man in 2011 and the Area (in %) of Malawi in 2012?
Offer a very short reply. 13.85. What is the difference between the Area (in %) in Austria in 2011 and the Area (in %) in Botswana in 2013?
Give a very brief answer. -7.12. What is the difference between the Area (in %) of Austria in 2011 and the Area (in %) of Isle of Man in 2013?
Provide a short and direct response. -29.54. What is the difference between the Area (in %) in Austria in 2011 and the Area (in %) in Malawi in 2013?
Offer a terse response. -22.88. What is the difference between the Area (in %) in Botswana in 2011 and the Area (in %) in Isle of Man in 2013?
Offer a very short reply. -22.32. What is the difference between the Area (in %) of Botswana in 2011 and the Area (in %) of Malawi in 2013?
Give a very brief answer. -15.67. What is the difference between the Area (in %) in Isle of Man in 2011 and the Area (in %) in Malawi in 2013?
Your answer should be compact. 13.27. What is the difference between the Area (in %) of Austria in 2012 and the Area (in %) of Botswana in 2013?
Ensure brevity in your answer.  -7.3. What is the difference between the Area (in %) in Austria in 2012 and the Area (in %) in Isle of Man in 2013?
Your response must be concise. -29.72. What is the difference between the Area (in %) in Austria in 2012 and the Area (in %) in Malawi in 2013?
Provide a short and direct response. -23.06. What is the difference between the Area (in %) of Botswana in 2012 and the Area (in %) of Isle of Man in 2013?
Provide a succinct answer. -22.39. What is the difference between the Area (in %) in Botswana in 2012 and the Area (in %) in Malawi in 2013?
Your answer should be compact. -15.73. What is the difference between the Area (in %) of Isle of Man in 2012 and the Area (in %) of Malawi in 2013?
Give a very brief answer. 5.96. What is the average Area (in %) in Austria per year?
Offer a very short reply. 38.68. What is the average Area (in %) in Botswana per year?
Keep it short and to the point. 45.64. What is the average Area (in %) in Isle of Man per year?
Your response must be concise. 73.54. What is the average Area (in %) of Malawi per year?
Your answer should be very brief. 58.32. In the year 2006, what is the difference between the Area (in %) of Austria and Area (in %) of Botswana?
Your answer should be very brief. -6.35. In the year 2006, what is the difference between the Area (in %) in Austria and Area (in %) in Isle of Man?
Give a very brief answer. -35.03. In the year 2006, what is the difference between the Area (in %) in Austria and Area (in %) in Malawi?
Keep it short and to the point. -16.88. In the year 2006, what is the difference between the Area (in %) of Botswana and Area (in %) of Isle of Man?
Provide a succinct answer. -28.68. In the year 2006, what is the difference between the Area (in %) in Botswana and Area (in %) in Malawi?
Provide a succinct answer. -10.53. In the year 2006, what is the difference between the Area (in %) of Isle of Man and Area (in %) of Malawi?
Give a very brief answer. 18.15. In the year 2007, what is the difference between the Area (in %) in Austria and Area (in %) in Botswana?
Provide a succinct answer. -6.33. In the year 2007, what is the difference between the Area (in %) in Austria and Area (in %) in Isle of Man?
Your response must be concise. -34.87. In the year 2007, what is the difference between the Area (in %) in Austria and Area (in %) in Malawi?
Give a very brief answer. -13.71. In the year 2007, what is the difference between the Area (in %) of Botswana and Area (in %) of Isle of Man?
Ensure brevity in your answer.  -28.54. In the year 2007, what is the difference between the Area (in %) in Botswana and Area (in %) in Malawi?
Your answer should be very brief. -7.38. In the year 2007, what is the difference between the Area (in %) of Isle of Man and Area (in %) of Malawi?
Your response must be concise. 21.16. In the year 2008, what is the difference between the Area (in %) of Austria and Area (in %) of Botswana?
Your answer should be very brief. -6.89. In the year 2008, what is the difference between the Area (in %) of Austria and Area (in %) of Isle of Man?
Provide a short and direct response. -38.95. In the year 2008, what is the difference between the Area (in %) of Austria and Area (in %) of Malawi?
Provide a succinct answer. -18.87. In the year 2008, what is the difference between the Area (in %) of Botswana and Area (in %) of Isle of Man?
Offer a terse response. -32.05. In the year 2008, what is the difference between the Area (in %) in Botswana and Area (in %) in Malawi?
Your response must be concise. -11.98. In the year 2008, what is the difference between the Area (in %) in Isle of Man and Area (in %) in Malawi?
Ensure brevity in your answer.  20.07. In the year 2009, what is the difference between the Area (in %) in Austria and Area (in %) in Botswana?
Provide a short and direct response. -7.05. In the year 2009, what is the difference between the Area (in %) in Austria and Area (in %) in Isle of Man?
Your response must be concise. -37.44. In the year 2009, what is the difference between the Area (in %) of Austria and Area (in %) of Malawi?
Your response must be concise. -19.5. In the year 2009, what is the difference between the Area (in %) in Botswana and Area (in %) in Isle of Man?
Provide a short and direct response. -30.39. In the year 2009, what is the difference between the Area (in %) in Botswana and Area (in %) in Malawi?
Offer a very short reply. -12.45. In the year 2009, what is the difference between the Area (in %) in Isle of Man and Area (in %) in Malawi?
Offer a very short reply. 17.95. In the year 2010, what is the difference between the Area (in %) of Austria and Area (in %) of Botswana?
Provide a short and direct response. -7.06. In the year 2010, what is the difference between the Area (in %) of Austria and Area (in %) of Isle of Man?
Your answer should be compact. -37.53. In the year 2010, what is the difference between the Area (in %) of Austria and Area (in %) of Malawi?
Provide a short and direct response. -21.72. In the year 2010, what is the difference between the Area (in %) of Botswana and Area (in %) of Isle of Man?
Offer a very short reply. -30.47. In the year 2010, what is the difference between the Area (in %) in Botswana and Area (in %) in Malawi?
Offer a very short reply. -14.67. In the year 2010, what is the difference between the Area (in %) in Isle of Man and Area (in %) in Malawi?
Your answer should be compact. 15.81. In the year 2011, what is the difference between the Area (in %) in Austria and Area (in %) in Botswana?
Provide a short and direct response. -7.22. In the year 2011, what is the difference between the Area (in %) of Austria and Area (in %) of Isle of Man?
Ensure brevity in your answer.  -36.15. In the year 2011, what is the difference between the Area (in %) of Austria and Area (in %) of Malawi?
Your answer should be very brief. -20.71. In the year 2011, what is the difference between the Area (in %) of Botswana and Area (in %) of Isle of Man?
Ensure brevity in your answer.  -28.94. In the year 2011, what is the difference between the Area (in %) of Botswana and Area (in %) of Malawi?
Your answer should be very brief. -13.49. In the year 2011, what is the difference between the Area (in %) in Isle of Man and Area (in %) in Malawi?
Give a very brief answer. 15.45. In the year 2012, what is the difference between the Area (in %) of Austria and Area (in %) of Botswana?
Provide a succinct answer. -7.33. In the year 2012, what is the difference between the Area (in %) of Austria and Area (in %) of Isle of Man?
Keep it short and to the point. -29.02. In the year 2012, what is the difference between the Area (in %) of Austria and Area (in %) of Malawi?
Ensure brevity in your answer.  -22.48. In the year 2012, what is the difference between the Area (in %) in Botswana and Area (in %) in Isle of Man?
Provide a succinct answer. -21.69. In the year 2012, what is the difference between the Area (in %) of Botswana and Area (in %) of Malawi?
Make the answer very short. -15.15. In the year 2012, what is the difference between the Area (in %) of Isle of Man and Area (in %) of Malawi?
Make the answer very short. 6.54. In the year 2013, what is the difference between the Area (in %) in Austria and Area (in %) in Botswana?
Offer a terse response. -7.43. In the year 2013, what is the difference between the Area (in %) in Austria and Area (in %) in Isle of Man?
Provide a short and direct response. -29.85. In the year 2013, what is the difference between the Area (in %) of Austria and Area (in %) of Malawi?
Your response must be concise. -23.19. In the year 2013, what is the difference between the Area (in %) of Botswana and Area (in %) of Isle of Man?
Ensure brevity in your answer.  -22.42. In the year 2013, what is the difference between the Area (in %) of Botswana and Area (in %) of Malawi?
Give a very brief answer. -15.76. In the year 2013, what is the difference between the Area (in %) of Isle of Man and Area (in %) of Malawi?
Your answer should be compact. 6.66. What is the ratio of the Area (in %) in Botswana in 2006 to that in 2007?
Offer a terse response. 1. What is the ratio of the Area (in %) in Malawi in 2006 to that in 2007?
Your response must be concise. 1.06. What is the ratio of the Area (in %) in Austria in 2006 to that in 2008?
Make the answer very short. 1.01. What is the ratio of the Area (in %) of Isle of Man in 2006 to that in 2008?
Your response must be concise. 0.95. What is the ratio of the Area (in %) of Malawi in 2006 to that in 2008?
Offer a very short reply. 0.97. What is the ratio of the Area (in %) in Austria in 2006 to that in 2009?
Offer a terse response. 1.01. What is the ratio of the Area (in %) in Botswana in 2006 to that in 2009?
Your answer should be very brief. 1. What is the ratio of the Area (in %) in Isle of Man in 2006 to that in 2009?
Your answer should be compact. 0.97. What is the ratio of the Area (in %) in Malawi in 2006 to that in 2009?
Provide a succinct answer. 0.96. What is the ratio of the Area (in %) of Austria in 2006 to that in 2010?
Offer a very short reply. 1.02. What is the ratio of the Area (in %) of Isle of Man in 2006 to that in 2010?
Offer a very short reply. 0.98. What is the ratio of the Area (in %) of Malawi in 2006 to that in 2010?
Your answer should be very brief. 0.93. What is the ratio of the Area (in %) of Austria in 2006 to that in 2011?
Give a very brief answer. 1.02. What is the ratio of the Area (in %) of Botswana in 2006 to that in 2011?
Your answer should be very brief. 1. What is the ratio of the Area (in %) of Isle of Man in 2006 to that in 2011?
Offer a terse response. 0.99. What is the ratio of the Area (in %) in Malawi in 2006 to that in 2011?
Ensure brevity in your answer.  0.95. What is the ratio of the Area (in %) in Austria in 2006 to that in 2012?
Ensure brevity in your answer.  1.02. What is the ratio of the Area (in %) in Botswana in 2006 to that in 2012?
Provide a succinct answer. 1. What is the ratio of the Area (in %) in Isle of Man in 2006 to that in 2012?
Make the answer very short. 1.1. What is the ratio of the Area (in %) of Malawi in 2006 to that in 2012?
Ensure brevity in your answer.  0.92. What is the ratio of the Area (in %) of Austria in 2006 to that in 2013?
Keep it short and to the point. 1.03. What is the ratio of the Area (in %) in Isle of Man in 2006 to that in 2013?
Provide a succinct answer. 1.09. What is the ratio of the Area (in %) in Malawi in 2006 to that in 2013?
Your answer should be compact. 0.91. What is the ratio of the Area (in %) in Austria in 2007 to that in 2008?
Provide a short and direct response. 1.01. What is the ratio of the Area (in %) in Botswana in 2007 to that in 2008?
Provide a short and direct response. 1. What is the ratio of the Area (in %) in Isle of Man in 2007 to that in 2008?
Offer a very short reply. 0.95. What is the ratio of the Area (in %) of Malawi in 2007 to that in 2008?
Keep it short and to the point. 0.92. What is the ratio of the Area (in %) in Austria in 2007 to that in 2009?
Offer a terse response. 1.01. What is the ratio of the Area (in %) of Isle of Man in 2007 to that in 2009?
Offer a terse response. 0.97. What is the ratio of the Area (in %) in Malawi in 2007 to that in 2009?
Provide a short and direct response. 0.91. What is the ratio of the Area (in %) of Austria in 2007 to that in 2010?
Keep it short and to the point. 1.02. What is the ratio of the Area (in %) in Botswana in 2007 to that in 2010?
Give a very brief answer. 1. What is the ratio of the Area (in %) of Isle of Man in 2007 to that in 2010?
Provide a succinct answer. 0.97. What is the ratio of the Area (in %) of Malawi in 2007 to that in 2010?
Your answer should be very brief. 0.88. What is the ratio of the Area (in %) in Austria in 2007 to that in 2011?
Your answer should be compact. 1.02. What is the ratio of the Area (in %) of Botswana in 2007 to that in 2011?
Give a very brief answer. 0.99. What is the ratio of the Area (in %) of Malawi in 2007 to that in 2011?
Your answer should be compact. 0.89. What is the ratio of the Area (in %) of Austria in 2007 to that in 2012?
Give a very brief answer. 1.02. What is the ratio of the Area (in %) in Botswana in 2007 to that in 2012?
Keep it short and to the point. 1. What is the ratio of the Area (in %) of Isle of Man in 2007 to that in 2012?
Your answer should be very brief. 1.1. What is the ratio of the Area (in %) of Malawi in 2007 to that in 2012?
Provide a succinct answer. 0.87. What is the ratio of the Area (in %) of Austria in 2007 to that in 2013?
Make the answer very short. 1.02. What is the ratio of the Area (in %) of Isle of Man in 2007 to that in 2013?
Provide a succinct answer. 1.09. What is the ratio of the Area (in %) in Malawi in 2007 to that in 2013?
Your answer should be very brief. 0.86. What is the ratio of the Area (in %) of Austria in 2008 to that in 2009?
Your answer should be very brief. 1. What is the ratio of the Area (in %) of Botswana in 2008 to that in 2009?
Provide a succinct answer. 1. What is the ratio of the Area (in %) in Isle of Man in 2008 to that in 2009?
Your answer should be compact. 1.02. What is the ratio of the Area (in %) in Malawi in 2008 to that in 2009?
Keep it short and to the point. 0.99. What is the ratio of the Area (in %) in Austria in 2008 to that in 2010?
Your response must be concise. 1.01. What is the ratio of the Area (in %) in Isle of Man in 2008 to that in 2010?
Your response must be concise. 1.02. What is the ratio of the Area (in %) of Malawi in 2008 to that in 2010?
Your response must be concise. 0.96. What is the ratio of the Area (in %) in Isle of Man in 2008 to that in 2011?
Give a very brief answer. 1.04. What is the ratio of the Area (in %) in Malawi in 2008 to that in 2011?
Provide a succinct answer. 0.97. What is the ratio of the Area (in %) in Isle of Man in 2008 to that in 2012?
Your response must be concise. 1.15. What is the ratio of the Area (in %) in Malawi in 2008 to that in 2012?
Your response must be concise. 0.95. What is the ratio of the Area (in %) in Austria in 2008 to that in 2013?
Offer a very short reply. 1.01. What is the ratio of the Area (in %) in Botswana in 2008 to that in 2013?
Provide a succinct answer. 1. What is the ratio of the Area (in %) in Isle of Man in 2008 to that in 2013?
Keep it short and to the point. 1.14. What is the ratio of the Area (in %) of Malawi in 2008 to that in 2013?
Offer a terse response. 0.94. What is the ratio of the Area (in %) of Isle of Man in 2009 to that in 2010?
Your response must be concise. 1. What is the ratio of the Area (in %) in Malawi in 2009 to that in 2010?
Provide a succinct answer. 0.96. What is the ratio of the Area (in %) of Austria in 2009 to that in 2011?
Your answer should be compact. 1. What is the ratio of the Area (in %) of Botswana in 2009 to that in 2011?
Your answer should be compact. 1. What is the ratio of the Area (in %) of Isle of Man in 2009 to that in 2011?
Provide a short and direct response. 1.02. What is the ratio of the Area (in %) in Malawi in 2009 to that in 2011?
Your answer should be very brief. 0.98. What is the ratio of the Area (in %) in Austria in 2009 to that in 2012?
Offer a terse response. 1.01. What is the ratio of the Area (in %) in Isle of Man in 2009 to that in 2012?
Your answer should be compact. 1.13. What is the ratio of the Area (in %) of Malawi in 2009 to that in 2012?
Provide a succinct answer. 0.96. What is the ratio of the Area (in %) in Botswana in 2009 to that in 2013?
Your answer should be very brief. 1. What is the ratio of the Area (in %) of Isle of Man in 2009 to that in 2013?
Give a very brief answer. 1.12. What is the ratio of the Area (in %) in Malawi in 2009 to that in 2013?
Provide a succinct answer. 0.95. What is the ratio of the Area (in %) in Austria in 2010 to that in 2011?
Your answer should be compact. 1. What is the ratio of the Area (in %) of Botswana in 2010 to that in 2011?
Make the answer very short. 1. What is the ratio of the Area (in %) of Malawi in 2010 to that in 2011?
Provide a succinct answer. 1.02. What is the ratio of the Area (in %) of Austria in 2010 to that in 2012?
Keep it short and to the point. 1.01. What is the ratio of the Area (in %) in Botswana in 2010 to that in 2012?
Your answer should be very brief. 1. What is the ratio of the Area (in %) in Isle of Man in 2010 to that in 2012?
Give a very brief answer. 1.13. What is the ratio of the Area (in %) of Malawi in 2010 to that in 2012?
Provide a succinct answer. 0.99. What is the ratio of the Area (in %) of Austria in 2010 to that in 2013?
Make the answer very short. 1.01. What is the ratio of the Area (in %) in Isle of Man in 2010 to that in 2013?
Provide a short and direct response. 1.12. What is the ratio of the Area (in %) in Malawi in 2010 to that in 2013?
Ensure brevity in your answer.  0.98. What is the ratio of the Area (in %) in Austria in 2011 to that in 2012?
Your answer should be very brief. 1. What is the ratio of the Area (in %) in Isle of Man in 2011 to that in 2012?
Give a very brief answer. 1.11. What is the ratio of the Area (in %) in Malawi in 2011 to that in 2012?
Make the answer very short. 0.97. What is the ratio of the Area (in %) in Botswana in 2011 to that in 2013?
Provide a short and direct response. 1. What is the ratio of the Area (in %) of Isle of Man in 2011 to that in 2013?
Offer a very short reply. 1.1. What is the ratio of the Area (in %) of Malawi in 2011 to that in 2013?
Offer a terse response. 0.96. What is the difference between the highest and the second highest Area (in %) of Austria?
Offer a terse response. 0.01. What is the difference between the highest and the second highest Area (in %) in Botswana?
Your answer should be very brief. 0.01. What is the difference between the highest and the second highest Area (in %) of Isle of Man?
Your answer should be compact. 1.6. What is the difference between the highest and the second highest Area (in %) in Malawi?
Provide a succinct answer. 0.58. What is the difference between the highest and the lowest Area (in %) in Austria?
Provide a succinct answer. 0.96. What is the difference between the highest and the lowest Area (in %) in Botswana?
Make the answer very short. 0.25. What is the difference between the highest and the lowest Area (in %) in Isle of Man?
Ensure brevity in your answer.  10.35. What is the difference between the highest and the lowest Area (in %) of Malawi?
Offer a very short reply. 8.54. 